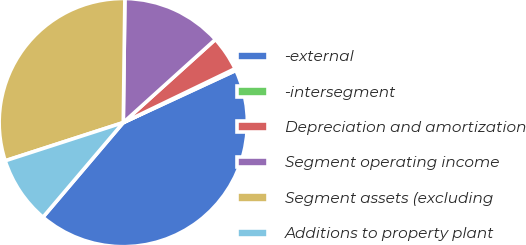Convert chart to OTSL. <chart><loc_0><loc_0><loc_500><loc_500><pie_chart><fcel>-external<fcel>-intersegment<fcel>Depreciation and amortization<fcel>Segment operating income<fcel>Segment assets (excluding<fcel>Additions to property plant<nl><fcel>43.11%<fcel>0.25%<fcel>4.53%<fcel>13.11%<fcel>30.19%<fcel>8.82%<nl></chart> 